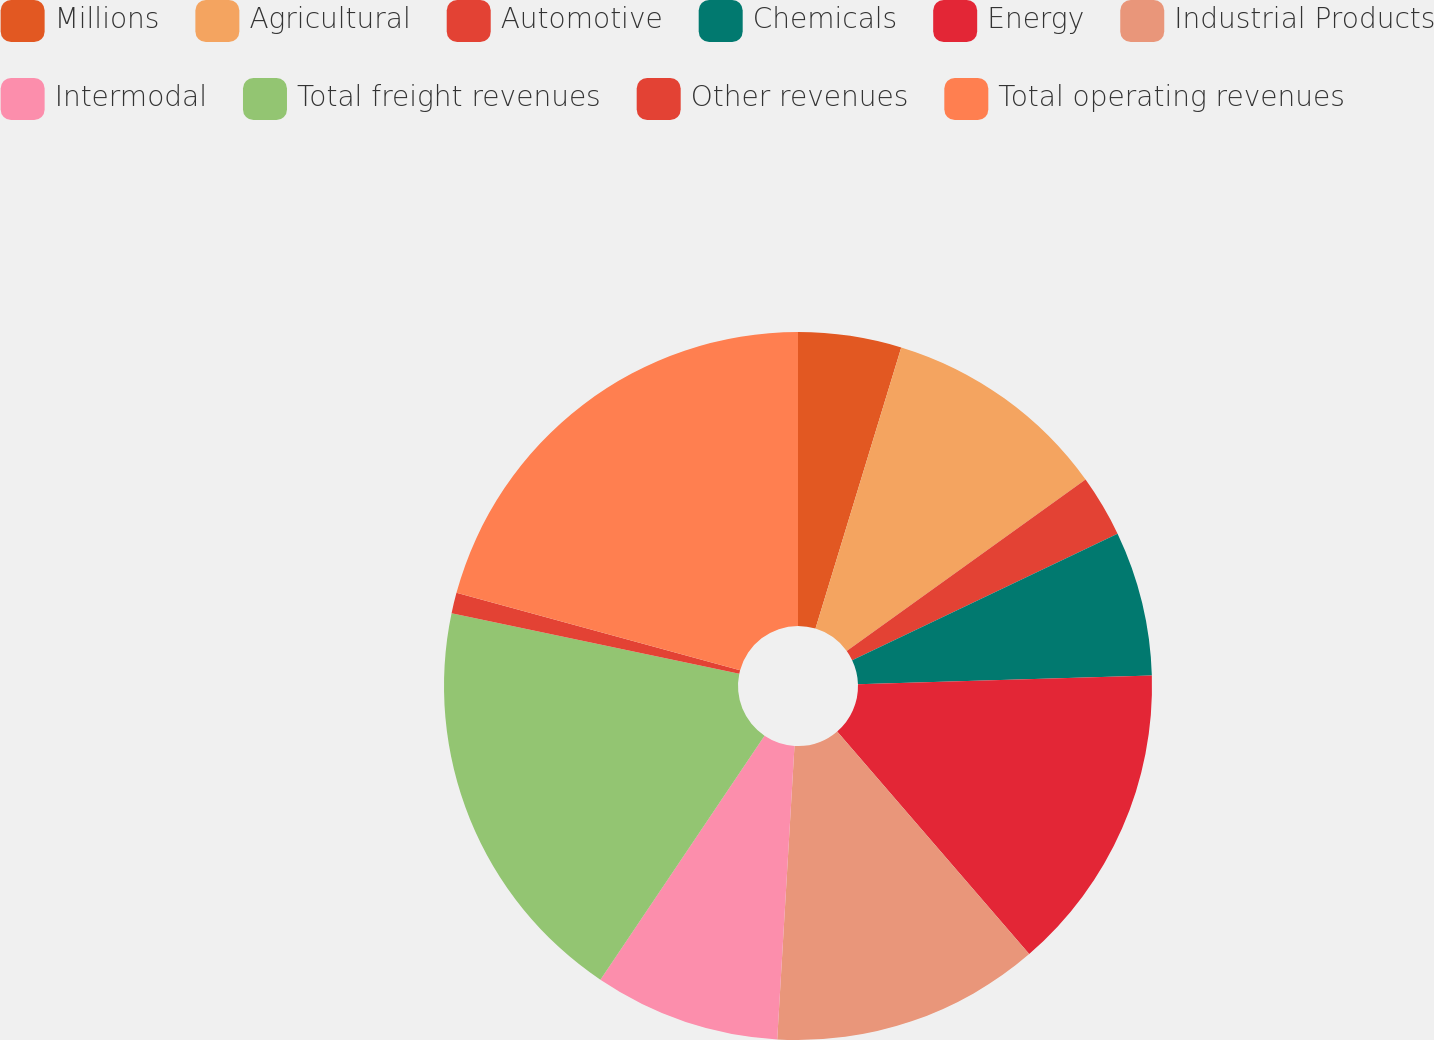Convert chart to OTSL. <chart><loc_0><loc_0><loc_500><loc_500><pie_chart><fcel>Millions<fcel>Agricultural<fcel>Automotive<fcel>Chemicals<fcel>Energy<fcel>Industrial Products<fcel>Intermodal<fcel>Total freight revenues<fcel>Other revenues<fcel>Total operating revenues<nl><fcel>4.71%<fcel>10.38%<fcel>2.83%<fcel>6.6%<fcel>14.15%<fcel>12.26%<fcel>8.49%<fcel>18.87%<fcel>0.94%<fcel>20.76%<nl></chart> 